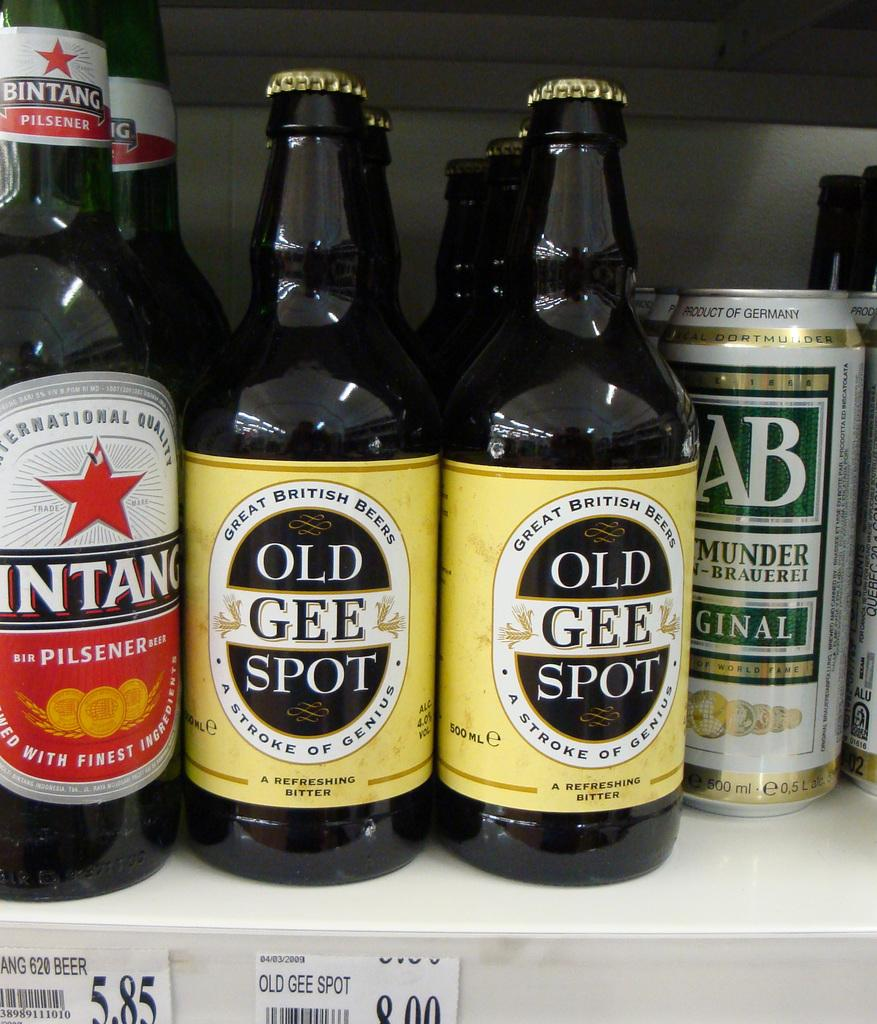<image>
Summarize the visual content of the image. Two Great British Bees Old Gee Spot, Bintang Pilsener, and cans of Ginalon on a shelf. 